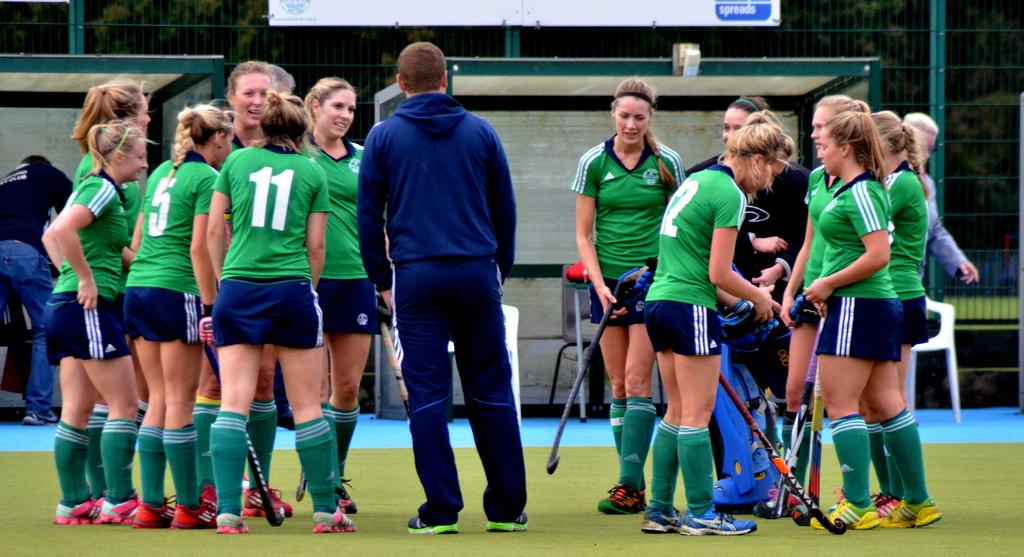What number is the girl on the left wearing ?
Your answer should be very brief. 5. What is the jersey number of the girl furthest on the left?
Give a very brief answer. 5. 